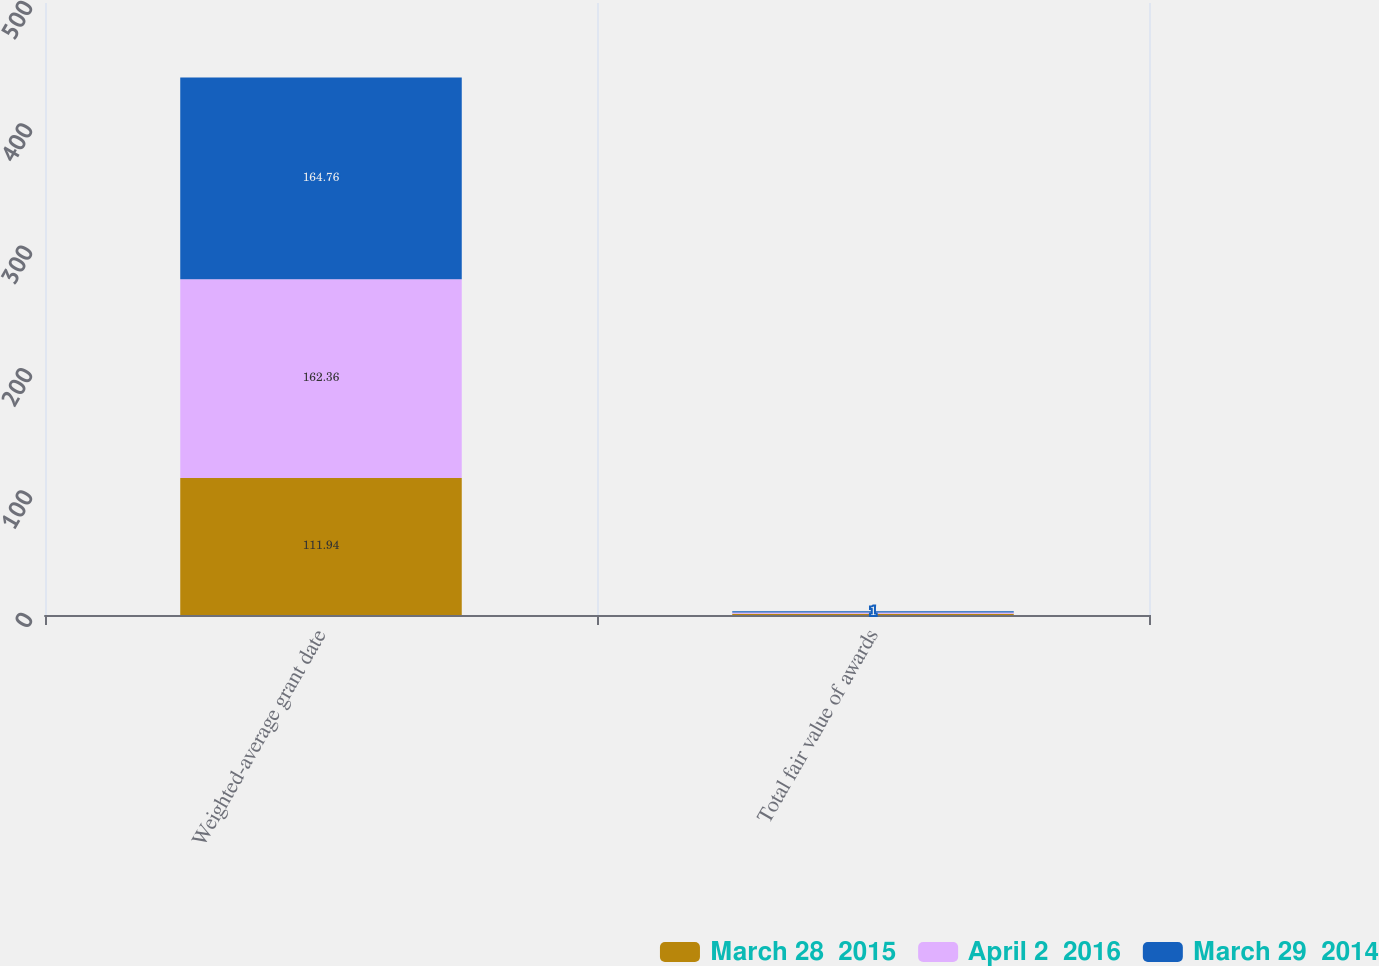Convert chart to OTSL. <chart><loc_0><loc_0><loc_500><loc_500><stacked_bar_chart><ecel><fcel>Weighted-average grant date<fcel>Total fair value of awards<nl><fcel>March 28  2015<fcel>111.94<fcel>1<nl><fcel>April 2  2016<fcel>162.36<fcel>1<nl><fcel>March 29  2014<fcel>164.76<fcel>1<nl></chart> 